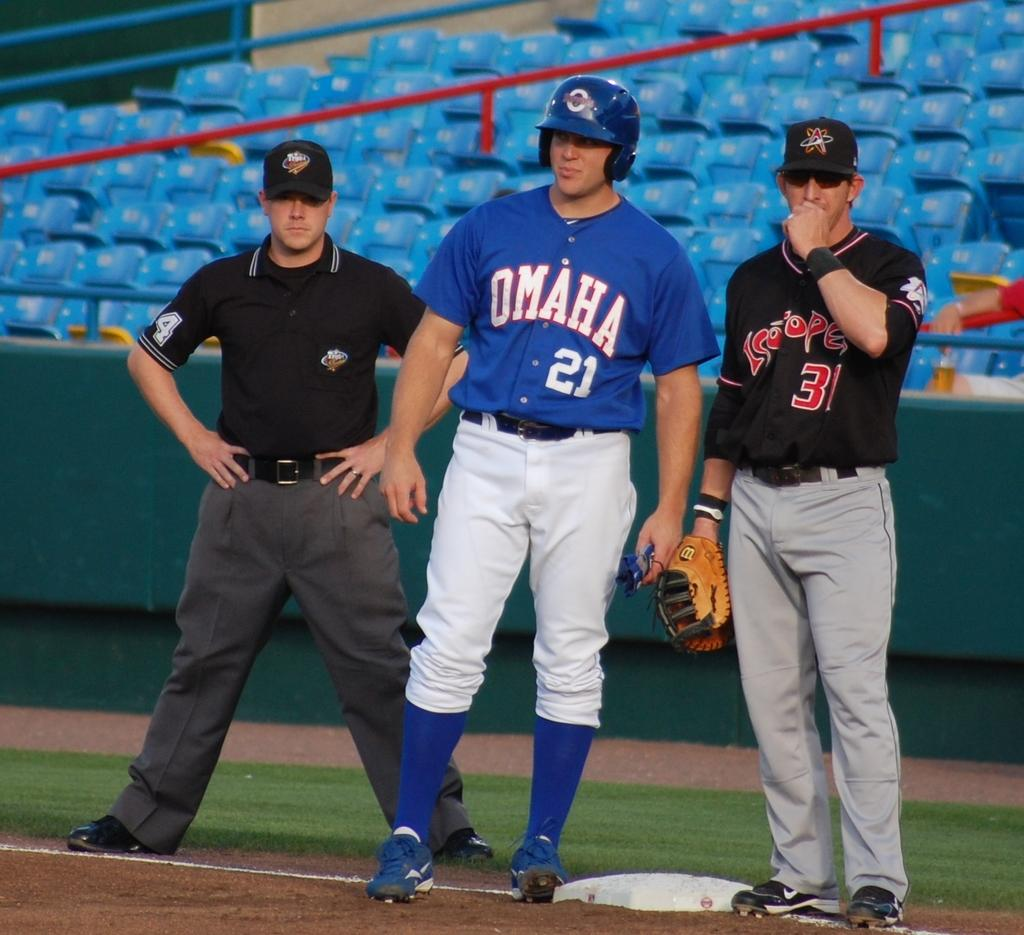<image>
Write a terse but informative summary of the picture. Player 21 from Omaha stands between an umpire and another player. 